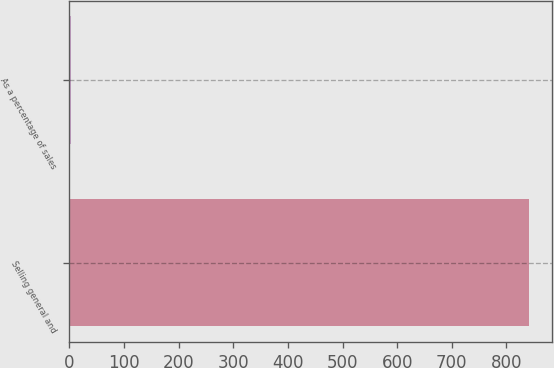Convert chart to OTSL. <chart><loc_0><loc_0><loc_500><loc_500><bar_chart><fcel>Selling general and<fcel>As a percentage of sales<nl><fcel>841<fcel>3.1<nl></chart> 